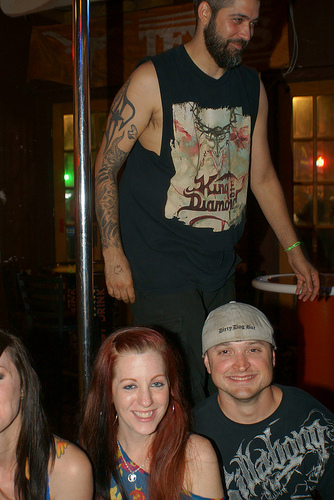<image>
Can you confirm if the pole is behind the woman? Yes. From this viewpoint, the pole is positioned behind the woman, with the woman partially or fully occluding the pole. Is the pole next to the man? Yes. The pole is positioned adjacent to the man, located nearby in the same general area. 